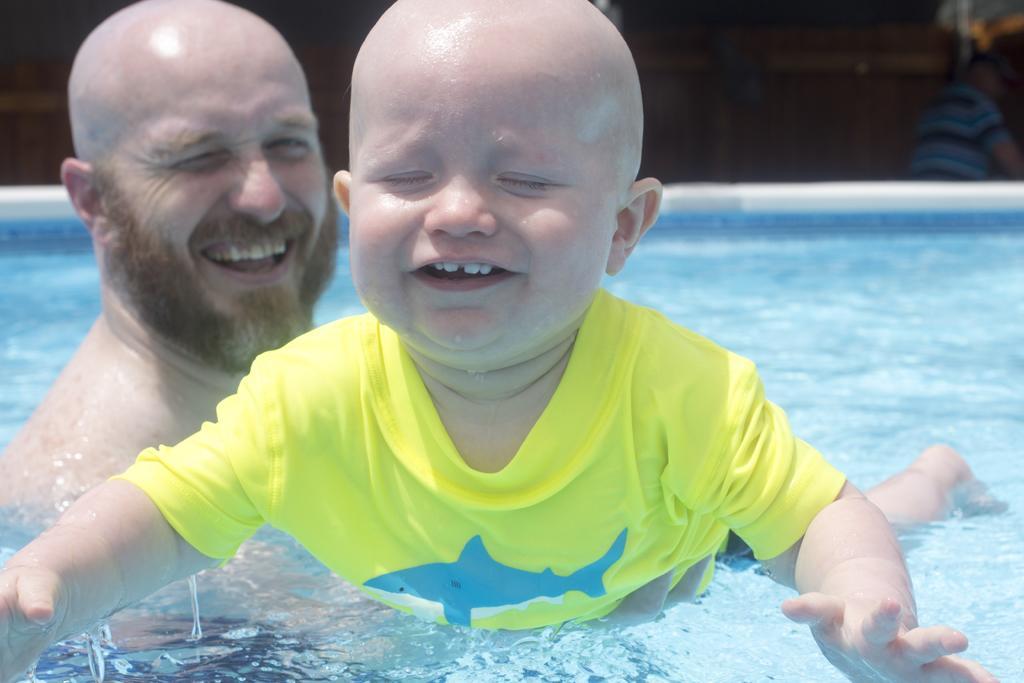Please provide a concise description of this image. In this image in front there are two persons in the swimming pool. Behind the swimming pool there is another person. 